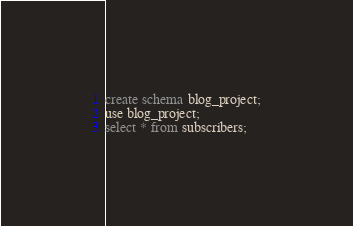<code> <loc_0><loc_0><loc_500><loc_500><_SQL_>create schema blog_project;
use blog_project;
select * from subscribers;</code> 